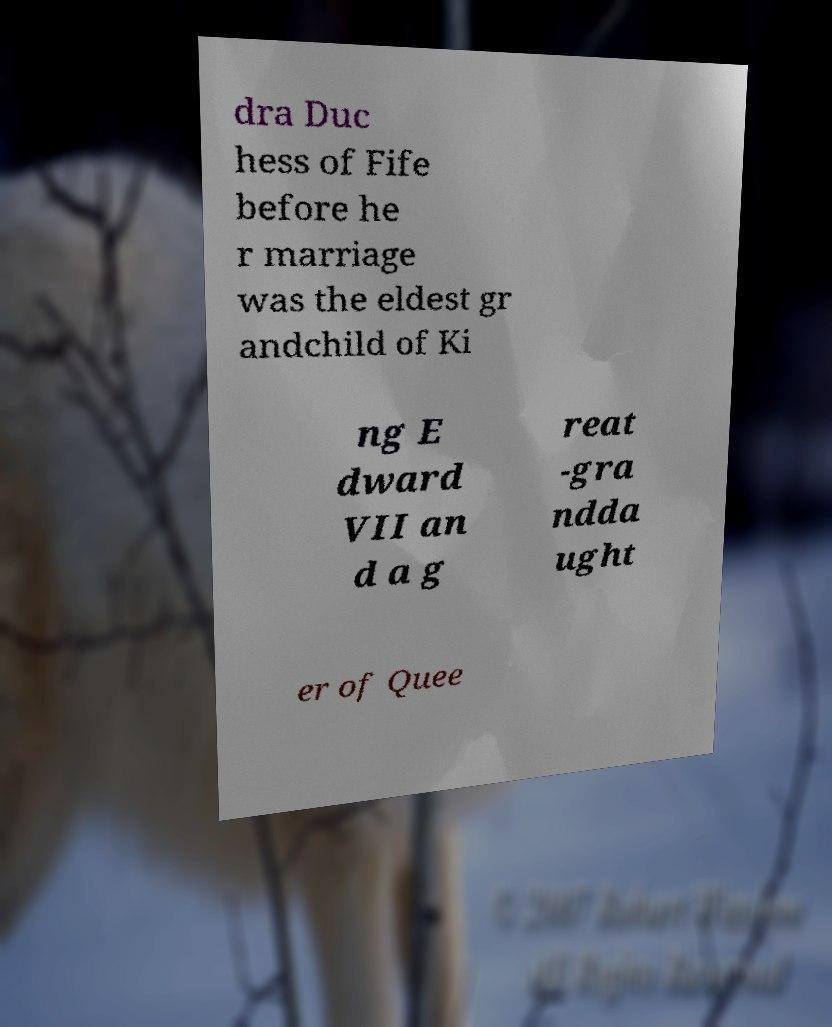Can you accurately transcribe the text from the provided image for me? dra Duc hess of Fife before he r marriage was the eldest gr andchild of Ki ng E dward VII an d a g reat -gra ndda ught er of Quee 